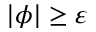Convert formula to latex. <formula><loc_0><loc_0><loc_500><loc_500>| \phi | \geq \varepsilon</formula> 